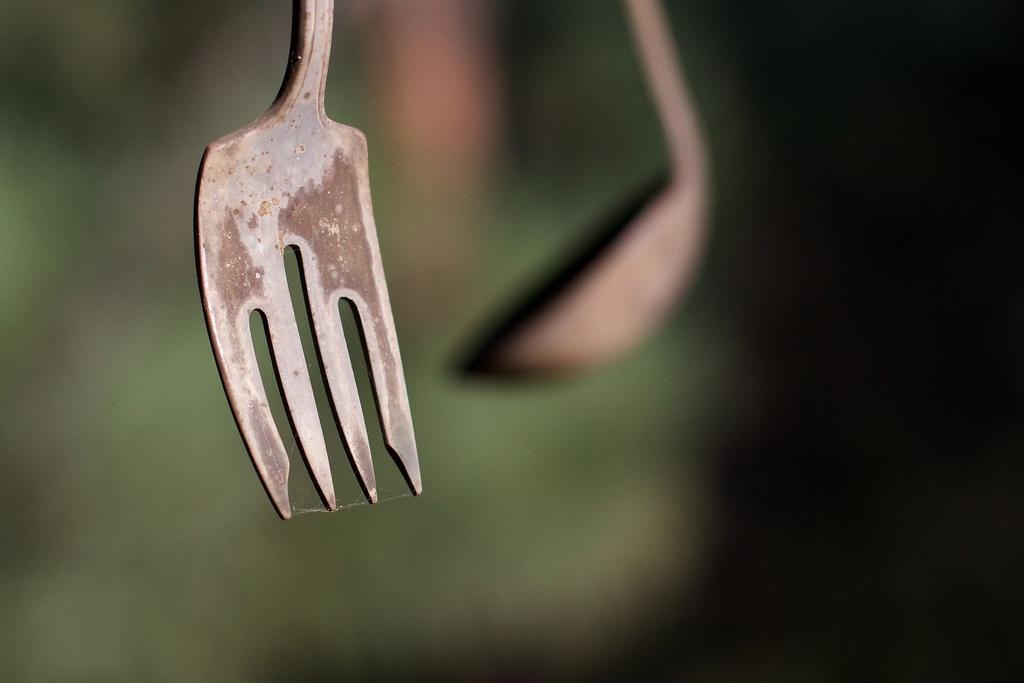Can you describe this image briefly? In this picture we can see a fork in the front, in the background there is a spoon, we can see a blurry background. 